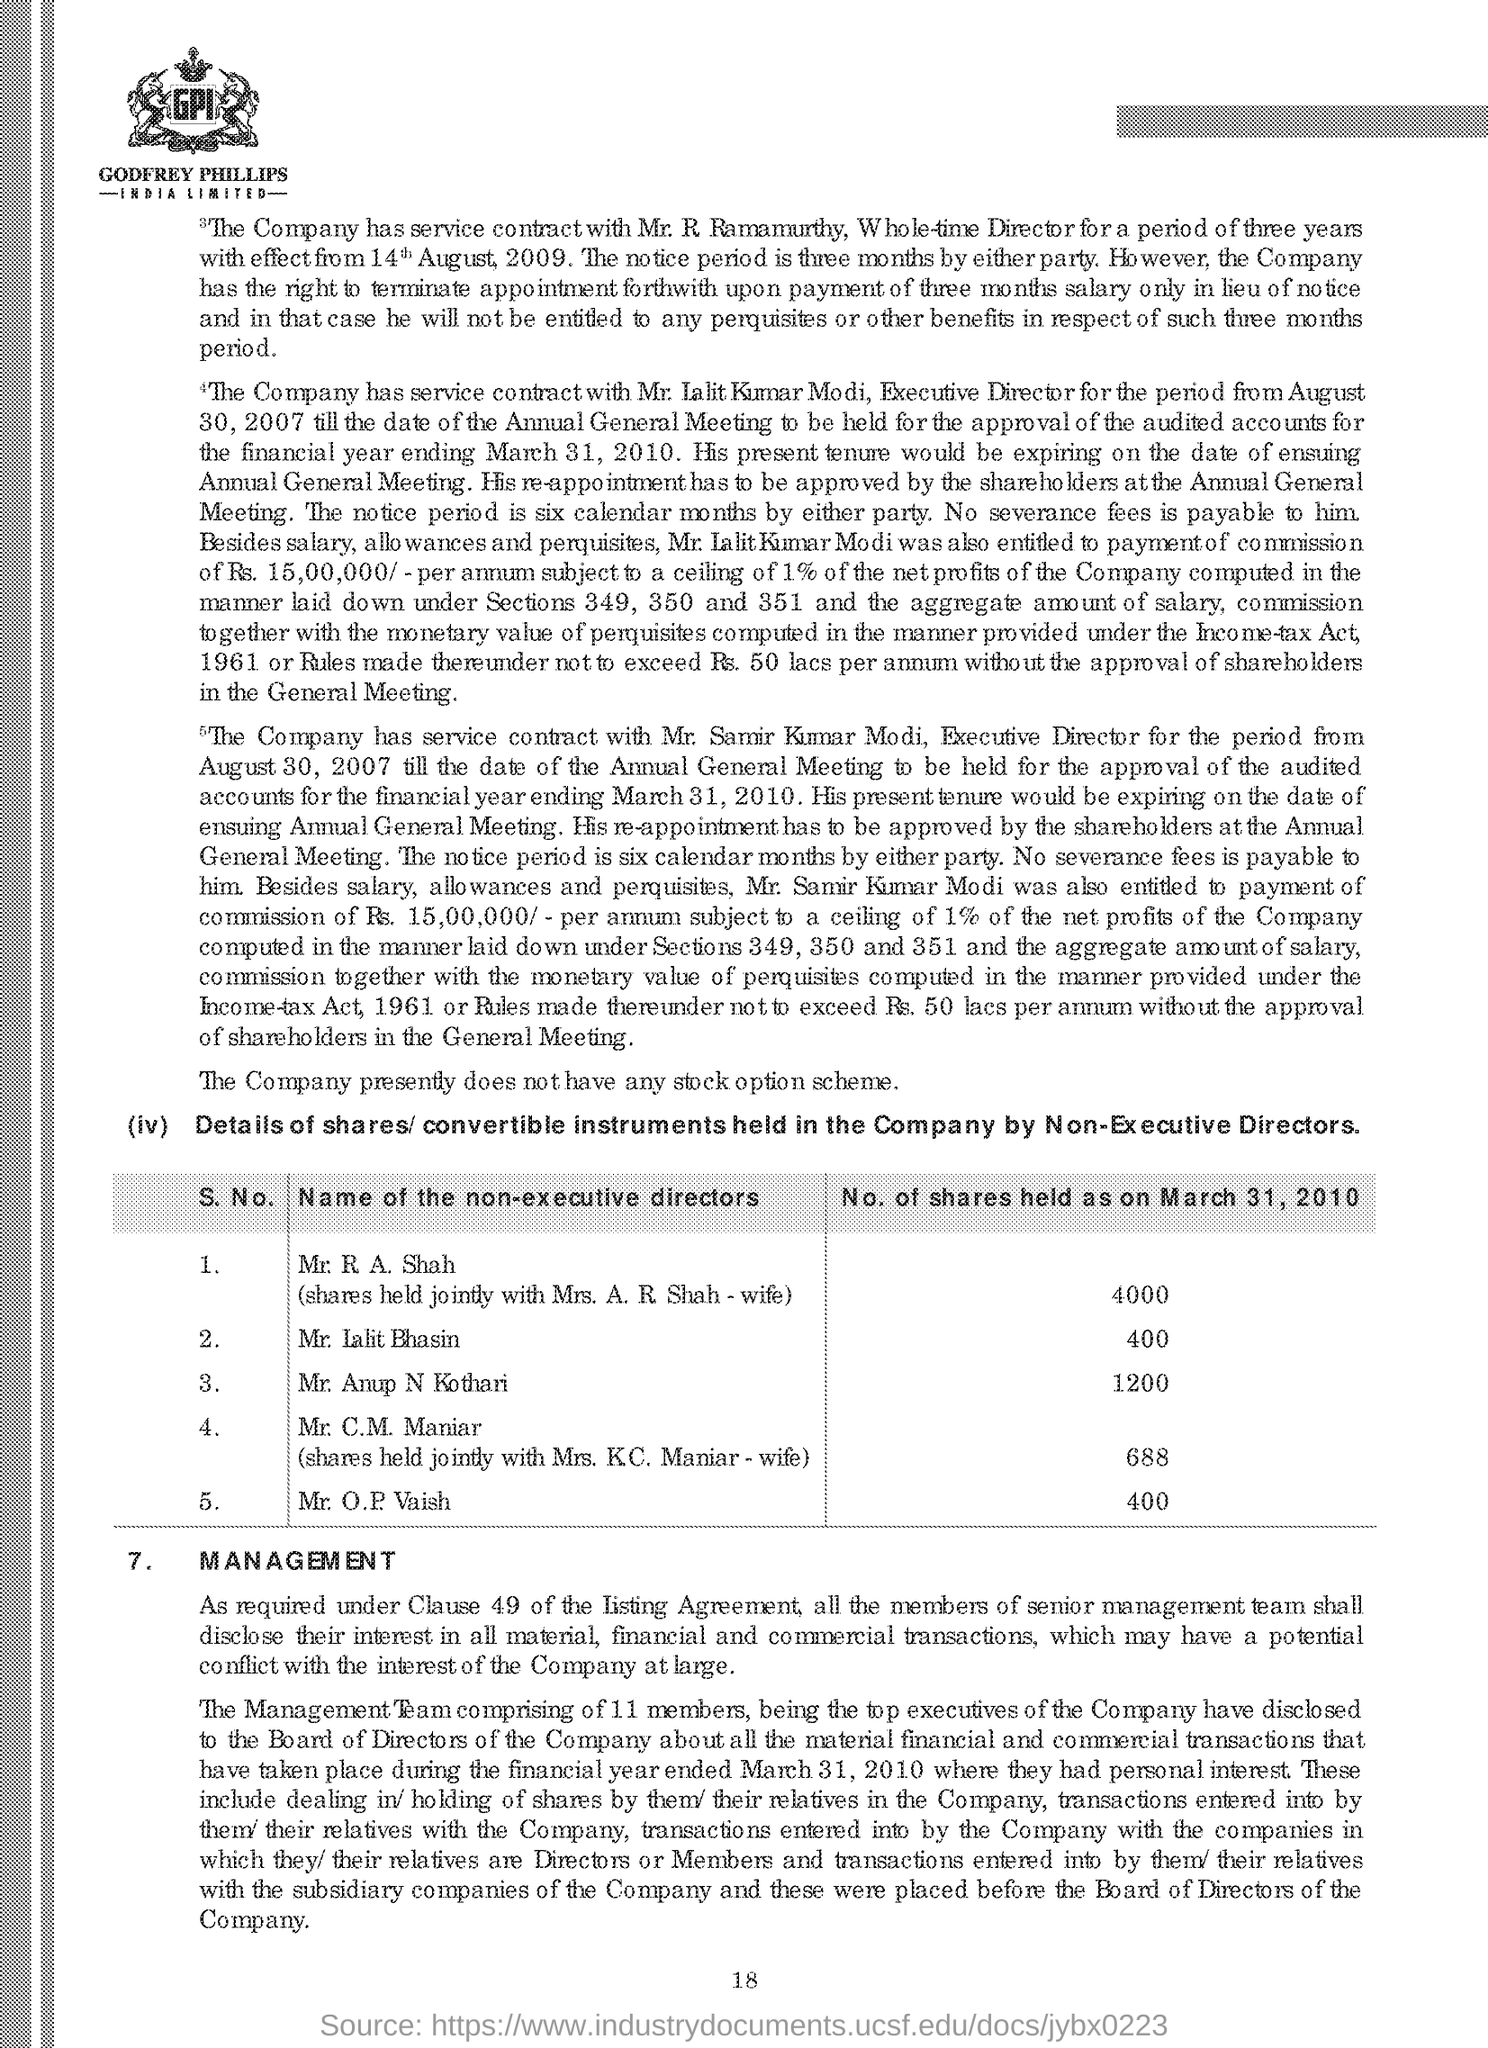Identify some key points in this picture. The page number is 18. The title "Management..." is the last title in the document. 